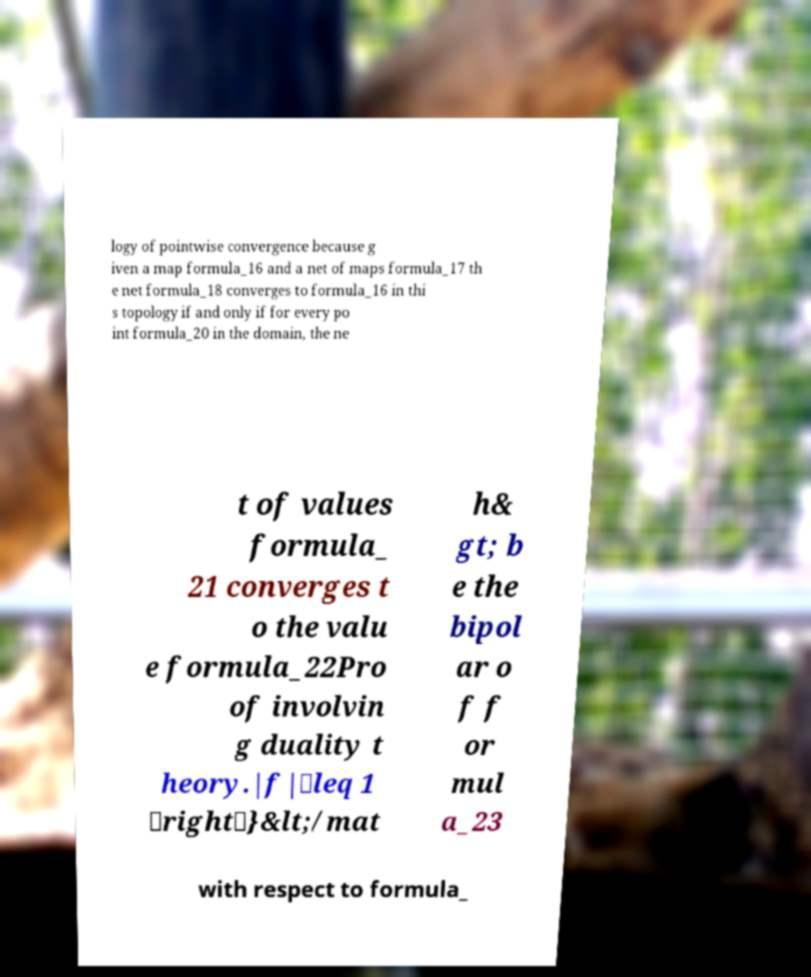There's text embedded in this image that I need extracted. Can you transcribe it verbatim? logy of pointwise convergence because g iven a map formula_16 and a net of maps formula_17 th e net formula_18 converges to formula_16 in thi s topology if and only if for every po int formula_20 in the domain, the ne t of values formula_ 21 converges t o the valu e formula_22Pro of involvin g duality t heory.|f|\leq 1 \right\}&lt;/mat h& gt; b e the bipol ar o f f or mul a_23 with respect to formula_ 